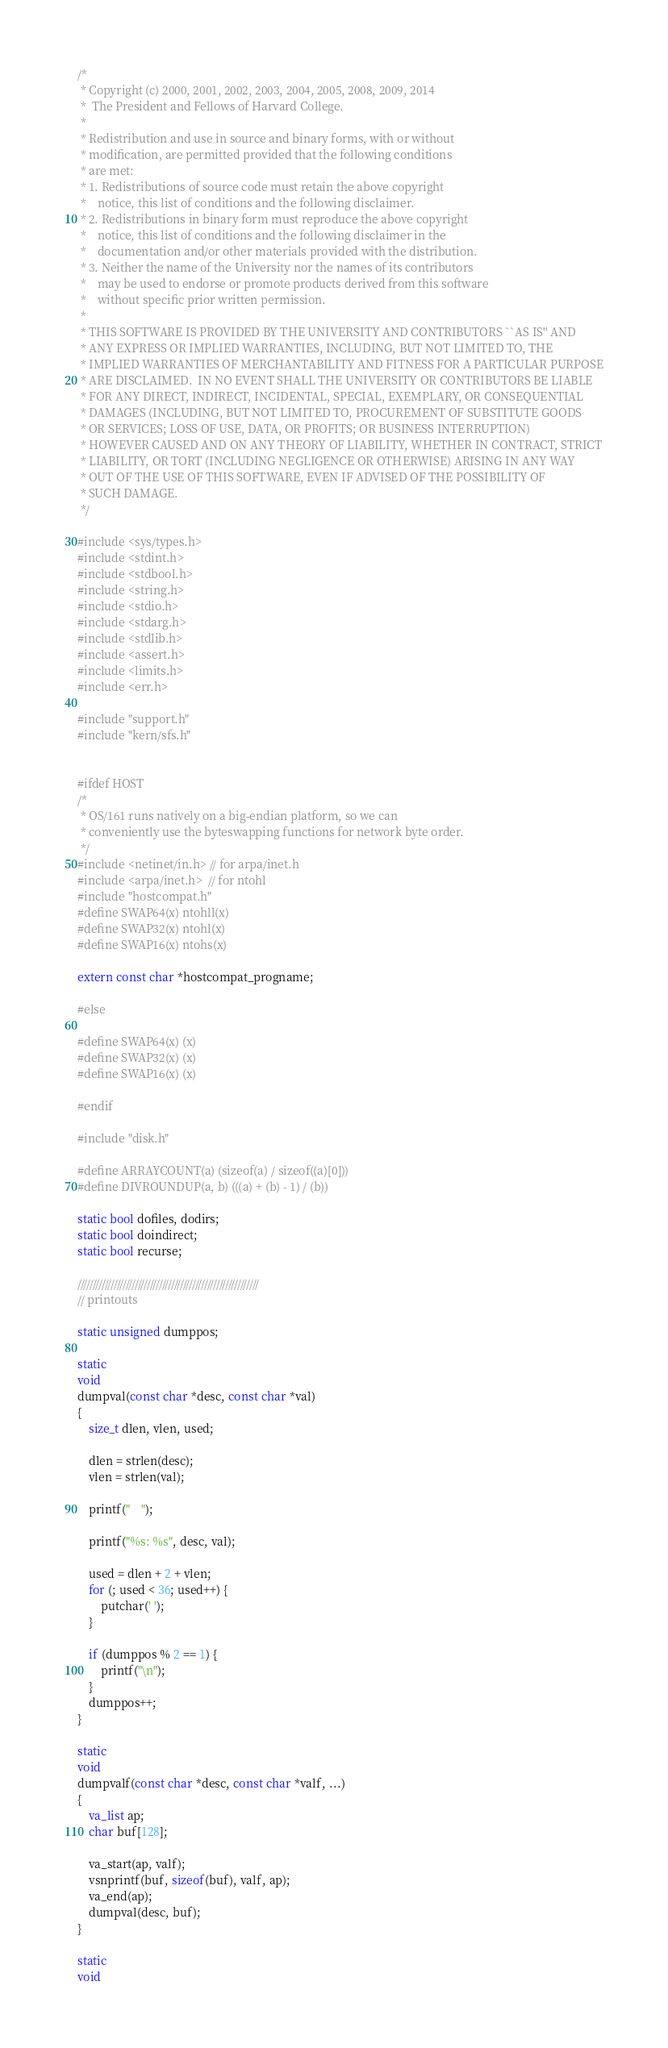<code> <loc_0><loc_0><loc_500><loc_500><_C_>/*
 * Copyright (c) 2000, 2001, 2002, 2003, 2004, 2005, 2008, 2009, 2014
 *	The President and Fellows of Harvard College.
 *
 * Redistribution and use in source and binary forms, with or without
 * modification, are permitted provided that the following conditions
 * are met:
 * 1. Redistributions of source code must retain the above copyright
 *    notice, this list of conditions and the following disclaimer.
 * 2. Redistributions in binary form must reproduce the above copyright
 *    notice, this list of conditions and the following disclaimer in the
 *    documentation and/or other materials provided with the distribution.
 * 3. Neither the name of the University nor the names of its contributors
 *    may be used to endorse or promote products derived from this software
 *    without specific prior written permission.
 *
 * THIS SOFTWARE IS PROVIDED BY THE UNIVERSITY AND CONTRIBUTORS ``AS IS'' AND
 * ANY EXPRESS OR IMPLIED WARRANTIES, INCLUDING, BUT NOT LIMITED TO, THE
 * IMPLIED WARRANTIES OF MERCHANTABILITY AND FITNESS FOR A PARTICULAR PURPOSE
 * ARE DISCLAIMED.  IN NO EVENT SHALL THE UNIVERSITY OR CONTRIBUTORS BE LIABLE
 * FOR ANY DIRECT, INDIRECT, INCIDENTAL, SPECIAL, EXEMPLARY, OR CONSEQUENTIAL
 * DAMAGES (INCLUDING, BUT NOT LIMITED TO, PROCUREMENT OF SUBSTITUTE GOODS
 * OR SERVICES; LOSS OF USE, DATA, OR PROFITS; OR BUSINESS INTERRUPTION)
 * HOWEVER CAUSED AND ON ANY THEORY OF LIABILITY, WHETHER IN CONTRACT, STRICT
 * LIABILITY, OR TORT (INCLUDING NEGLIGENCE OR OTHERWISE) ARISING IN ANY WAY
 * OUT OF THE USE OF THIS SOFTWARE, EVEN IF ADVISED OF THE POSSIBILITY OF
 * SUCH DAMAGE.
 */

#include <sys/types.h>
#include <stdint.h>
#include <stdbool.h>
#include <string.h>
#include <stdio.h>
#include <stdarg.h>
#include <stdlib.h>
#include <assert.h>
#include <limits.h>
#include <err.h>

#include "support.h"
#include "kern/sfs.h"


#ifdef HOST
/*
 * OS/161 runs natively on a big-endian platform, so we can
 * conveniently use the byteswapping functions for network byte order.
 */
#include <netinet/in.h> // for arpa/inet.h
#include <arpa/inet.h>  // for ntohl
#include "hostcompat.h"
#define SWAP64(x) ntohll(x)
#define SWAP32(x) ntohl(x)
#define SWAP16(x) ntohs(x)

extern const char *hostcompat_progname;

#else

#define SWAP64(x) (x)
#define SWAP32(x) (x)
#define SWAP16(x) (x)

#endif

#include "disk.h"

#define ARRAYCOUNT(a) (sizeof(a) / sizeof((a)[0]))
#define DIVROUNDUP(a, b) (((a) + (b) - 1) / (b))

static bool dofiles, dodirs;
static bool doindirect;
static bool recurse;

////////////////////////////////////////////////////////////
// printouts

static unsigned dumppos;

static
void
dumpval(const char *desc, const char *val)
{
	size_t dlen, vlen, used;

	dlen = strlen(desc);
	vlen = strlen(val);

	printf("    ");

	printf("%s: %s", desc, val);

	used = dlen + 2 + vlen;
	for (; used < 36; used++) {
		putchar(' ');
	}

	if (dumppos % 2 == 1) {
		printf("\n");
	}
	dumppos++;
}

static
void
dumpvalf(const char *desc, const char *valf, ...)
{
	va_list ap;
	char buf[128];

	va_start(ap, valf);
	vsnprintf(buf, sizeof(buf), valf, ap);
	va_end(ap);
	dumpval(desc, buf);
}

static
void</code> 